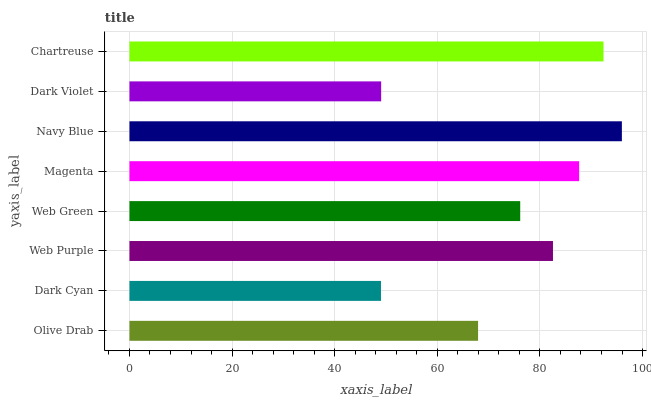Is Dark Cyan the minimum?
Answer yes or no. Yes. Is Navy Blue the maximum?
Answer yes or no. Yes. Is Web Purple the minimum?
Answer yes or no. No. Is Web Purple the maximum?
Answer yes or no. No. Is Web Purple greater than Dark Cyan?
Answer yes or no. Yes. Is Dark Cyan less than Web Purple?
Answer yes or no. Yes. Is Dark Cyan greater than Web Purple?
Answer yes or no. No. Is Web Purple less than Dark Cyan?
Answer yes or no. No. Is Web Purple the high median?
Answer yes or no. Yes. Is Web Green the low median?
Answer yes or no. Yes. Is Navy Blue the high median?
Answer yes or no. No. Is Chartreuse the low median?
Answer yes or no. No. 